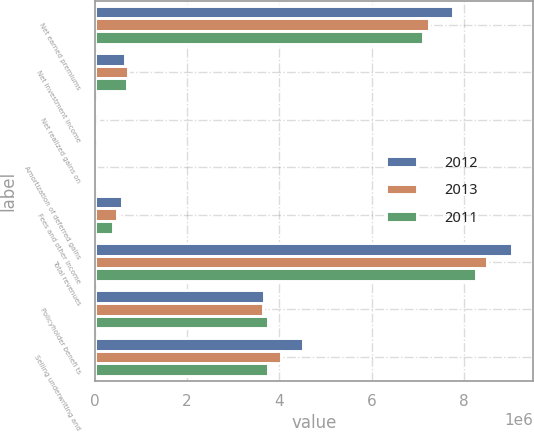<chart> <loc_0><loc_0><loc_500><loc_500><stacked_bar_chart><ecel><fcel>Net earned premiums<fcel>Net investment income<fcel>Net realized gains on<fcel>Amortization of deferred gains<fcel>Fees and other income<fcel>Total revenues<fcel>Policyholder benefi ts<fcel>Selling underwriting and<nl><fcel>2012<fcel>7.7598e+06<fcel>650296<fcel>34525<fcel>16310<fcel>586730<fcel>9.04766e+06<fcel>3.67553e+06<fcel>4.50469e+06<nl><fcel>2013<fcel>7.23698e+06<fcel>713128<fcel>64353<fcel>18413<fcel>475392<fcel>8.50827e+06<fcel>3.6554e+06<fcel>4.03481e+06<nl><fcel>2011<fcel>7.12537e+06<fcel>689532<fcel>32580<fcel>20461<fcel>404863<fcel>8.2728e+06<fcel>3.74973e+06<fcel>3.75658e+06<nl></chart> 